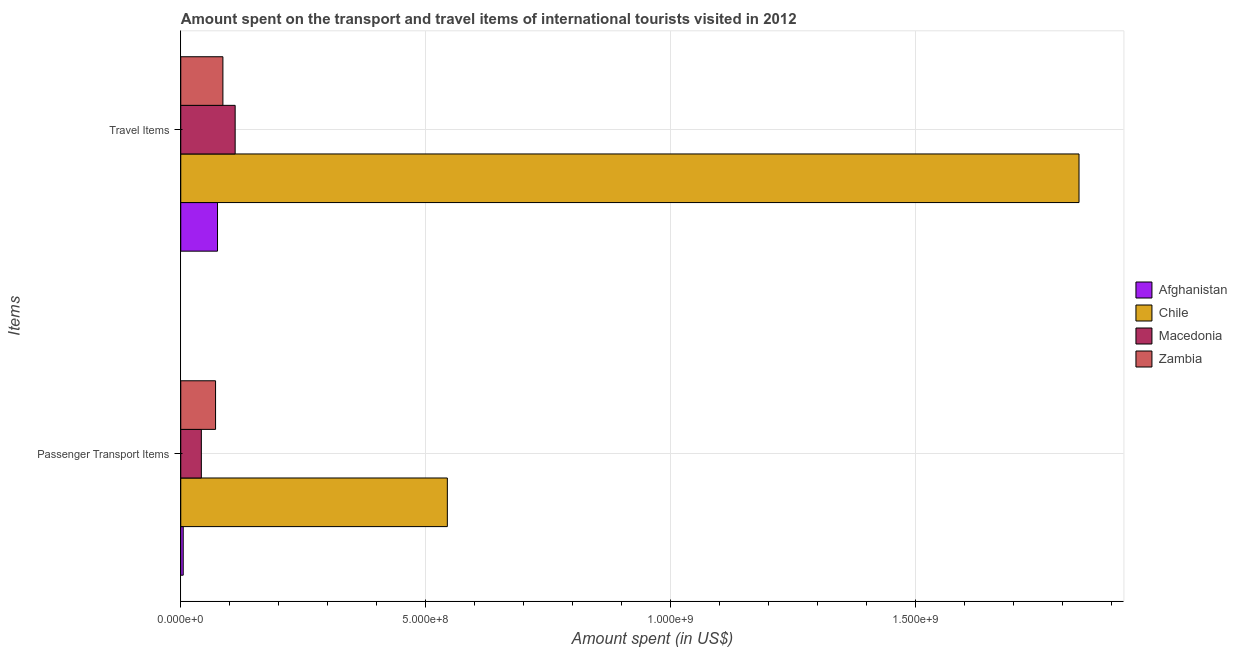How many different coloured bars are there?
Your answer should be compact. 4. Are the number of bars per tick equal to the number of legend labels?
Your response must be concise. Yes. How many bars are there on the 1st tick from the top?
Give a very brief answer. 4. What is the label of the 2nd group of bars from the top?
Offer a terse response. Passenger Transport Items. What is the amount spent on passenger transport items in Chile?
Keep it short and to the point. 5.44e+08. Across all countries, what is the maximum amount spent on passenger transport items?
Your answer should be compact. 5.44e+08. Across all countries, what is the minimum amount spent in travel items?
Provide a short and direct response. 7.50e+07. In which country was the amount spent on passenger transport items maximum?
Your answer should be very brief. Chile. In which country was the amount spent in travel items minimum?
Offer a terse response. Afghanistan. What is the total amount spent in travel items in the graph?
Ensure brevity in your answer.  2.10e+09. What is the difference between the amount spent in travel items in Macedonia and that in Zambia?
Your answer should be very brief. 2.50e+07. What is the difference between the amount spent on passenger transport items in Macedonia and the amount spent in travel items in Chile?
Ensure brevity in your answer.  -1.79e+09. What is the average amount spent on passenger transport items per country?
Offer a terse response. 1.66e+08. What is the difference between the amount spent in travel items and amount spent on passenger transport items in Chile?
Offer a terse response. 1.29e+09. What is the ratio of the amount spent in travel items in Chile to that in Macedonia?
Give a very brief answer. 16.51. Is the amount spent in travel items in Zambia less than that in Chile?
Your answer should be compact. Yes. What does the 4th bar from the top in Passenger Transport Items represents?
Your response must be concise. Afghanistan. What does the 1st bar from the bottom in Travel Items represents?
Offer a very short reply. Afghanistan. Are all the bars in the graph horizontal?
Your response must be concise. Yes. How many countries are there in the graph?
Ensure brevity in your answer.  4. Does the graph contain any zero values?
Your answer should be very brief. No. Does the graph contain grids?
Ensure brevity in your answer.  Yes. Where does the legend appear in the graph?
Ensure brevity in your answer.  Center right. What is the title of the graph?
Ensure brevity in your answer.  Amount spent on the transport and travel items of international tourists visited in 2012. Does "St. Lucia" appear as one of the legend labels in the graph?
Provide a succinct answer. No. What is the label or title of the X-axis?
Your response must be concise. Amount spent (in US$). What is the label or title of the Y-axis?
Your answer should be compact. Items. What is the Amount spent (in US$) of Chile in Passenger Transport Items?
Offer a very short reply. 5.44e+08. What is the Amount spent (in US$) in Macedonia in Passenger Transport Items?
Provide a short and direct response. 4.20e+07. What is the Amount spent (in US$) of Zambia in Passenger Transport Items?
Offer a terse response. 7.10e+07. What is the Amount spent (in US$) in Afghanistan in Travel Items?
Ensure brevity in your answer.  7.50e+07. What is the Amount spent (in US$) in Chile in Travel Items?
Ensure brevity in your answer.  1.83e+09. What is the Amount spent (in US$) in Macedonia in Travel Items?
Provide a short and direct response. 1.11e+08. What is the Amount spent (in US$) of Zambia in Travel Items?
Your answer should be very brief. 8.60e+07. Across all Items, what is the maximum Amount spent (in US$) in Afghanistan?
Make the answer very short. 7.50e+07. Across all Items, what is the maximum Amount spent (in US$) of Chile?
Ensure brevity in your answer.  1.83e+09. Across all Items, what is the maximum Amount spent (in US$) in Macedonia?
Ensure brevity in your answer.  1.11e+08. Across all Items, what is the maximum Amount spent (in US$) of Zambia?
Your response must be concise. 8.60e+07. Across all Items, what is the minimum Amount spent (in US$) of Afghanistan?
Offer a very short reply. 5.00e+06. Across all Items, what is the minimum Amount spent (in US$) of Chile?
Offer a very short reply. 5.44e+08. Across all Items, what is the minimum Amount spent (in US$) of Macedonia?
Your response must be concise. 4.20e+07. Across all Items, what is the minimum Amount spent (in US$) of Zambia?
Keep it short and to the point. 7.10e+07. What is the total Amount spent (in US$) of Afghanistan in the graph?
Offer a terse response. 8.00e+07. What is the total Amount spent (in US$) of Chile in the graph?
Your response must be concise. 2.38e+09. What is the total Amount spent (in US$) of Macedonia in the graph?
Keep it short and to the point. 1.53e+08. What is the total Amount spent (in US$) of Zambia in the graph?
Make the answer very short. 1.57e+08. What is the difference between the Amount spent (in US$) of Afghanistan in Passenger Transport Items and that in Travel Items?
Provide a short and direct response. -7.00e+07. What is the difference between the Amount spent (in US$) in Chile in Passenger Transport Items and that in Travel Items?
Offer a very short reply. -1.29e+09. What is the difference between the Amount spent (in US$) of Macedonia in Passenger Transport Items and that in Travel Items?
Give a very brief answer. -6.90e+07. What is the difference between the Amount spent (in US$) of Zambia in Passenger Transport Items and that in Travel Items?
Offer a terse response. -1.50e+07. What is the difference between the Amount spent (in US$) in Afghanistan in Passenger Transport Items and the Amount spent (in US$) in Chile in Travel Items?
Offer a terse response. -1.83e+09. What is the difference between the Amount spent (in US$) in Afghanistan in Passenger Transport Items and the Amount spent (in US$) in Macedonia in Travel Items?
Your answer should be very brief. -1.06e+08. What is the difference between the Amount spent (in US$) of Afghanistan in Passenger Transport Items and the Amount spent (in US$) of Zambia in Travel Items?
Make the answer very short. -8.10e+07. What is the difference between the Amount spent (in US$) of Chile in Passenger Transport Items and the Amount spent (in US$) of Macedonia in Travel Items?
Make the answer very short. 4.33e+08. What is the difference between the Amount spent (in US$) of Chile in Passenger Transport Items and the Amount spent (in US$) of Zambia in Travel Items?
Make the answer very short. 4.58e+08. What is the difference between the Amount spent (in US$) of Macedonia in Passenger Transport Items and the Amount spent (in US$) of Zambia in Travel Items?
Offer a terse response. -4.40e+07. What is the average Amount spent (in US$) of Afghanistan per Items?
Ensure brevity in your answer.  4.00e+07. What is the average Amount spent (in US$) of Chile per Items?
Give a very brief answer. 1.19e+09. What is the average Amount spent (in US$) of Macedonia per Items?
Your response must be concise. 7.65e+07. What is the average Amount spent (in US$) in Zambia per Items?
Offer a very short reply. 7.85e+07. What is the difference between the Amount spent (in US$) of Afghanistan and Amount spent (in US$) of Chile in Passenger Transport Items?
Your response must be concise. -5.39e+08. What is the difference between the Amount spent (in US$) of Afghanistan and Amount spent (in US$) of Macedonia in Passenger Transport Items?
Offer a terse response. -3.70e+07. What is the difference between the Amount spent (in US$) of Afghanistan and Amount spent (in US$) of Zambia in Passenger Transport Items?
Provide a succinct answer. -6.60e+07. What is the difference between the Amount spent (in US$) of Chile and Amount spent (in US$) of Macedonia in Passenger Transport Items?
Provide a succinct answer. 5.02e+08. What is the difference between the Amount spent (in US$) in Chile and Amount spent (in US$) in Zambia in Passenger Transport Items?
Give a very brief answer. 4.73e+08. What is the difference between the Amount spent (in US$) in Macedonia and Amount spent (in US$) in Zambia in Passenger Transport Items?
Your answer should be very brief. -2.90e+07. What is the difference between the Amount spent (in US$) of Afghanistan and Amount spent (in US$) of Chile in Travel Items?
Make the answer very short. -1.76e+09. What is the difference between the Amount spent (in US$) in Afghanistan and Amount spent (in US$) in Macedonia in Travel Items?
Your answer should be compact. -3.60e+07. What is the difference between the Amount spent (in US$) of Afghanistan and Amount spent (in US$) of Zambia in Travel Items?
Keep it short and to the point. -1.10e+07. What is the difference between the Amount spent (in US$) of Chile and Amount spent (in US$) of Macedonia in Travel Items?
Ensure brevity in your answer.  1.72e+09. What is the difference between the Amount spent (in US$) of Chile and Amount spent (in US$) of Zambia in Travel Items?
Your response must be concise. 1.75e+09. What is the difference between the Amount spent (in US$) of Macedonia and Amount spent (in US$) of Zambia in Travel Items?
Make the answer very short. 2.50e+07. What is the ratio of the Amount spent (in US$) in Afghanistan in Passenger Transport Items to that in Travel Items?
Your answer should be compact. 0.07. What is the ratio of the Amount spent (in US$) in Chile in Passenger Transport Items to that in Travel Items?
Provide a succinct answer. 0.3. What is the ratio of the Amount spent (in US$) in Macedonia in Passenger Transport Items to that in Travel Items?
Offer a terse response. 0.38. What is the ratio of the Amount spent (in US$) of Zambia in Passenger Transport Items to that in Travel Items?
Your answer should be very brief. 0.83. What is the difference between the highest and the second highest Amount spent (in US$) in Afghanistan?
Ensure brevity in your answer.  7.00e+07. What is the difference between the highest and the second highest Amount spent (in US$) of Chile?
Ensure brevity in your answer.  1.29e+09. What is the difference between the highest and the second highest Amount spent (in US$) of Macedonia?
Keep it short and to the point. 6.90e+07. What is the difference between the highest and the second highest Amount spent (in US$) in Zambia?
Make the answer very short. 1.50e+07. What is the difference between the highest and the lowest Amount spent (in US$) of Afghanistan?
Make the answer very short. 7.00e+07. What is the difference between the highest and the lowest Amount spent (in US$) of Chile?
Your answer should be compact. 1.29e+09. What is the difference between the highest and the lowest Amount spent (in US$) in Macedonia?
Keep it short and to the point. 6.90e+07. What is the difference between the highest and the lowest Amount spent (in US$) in Zambia?
Make the answer very short. 1.50e+07. 